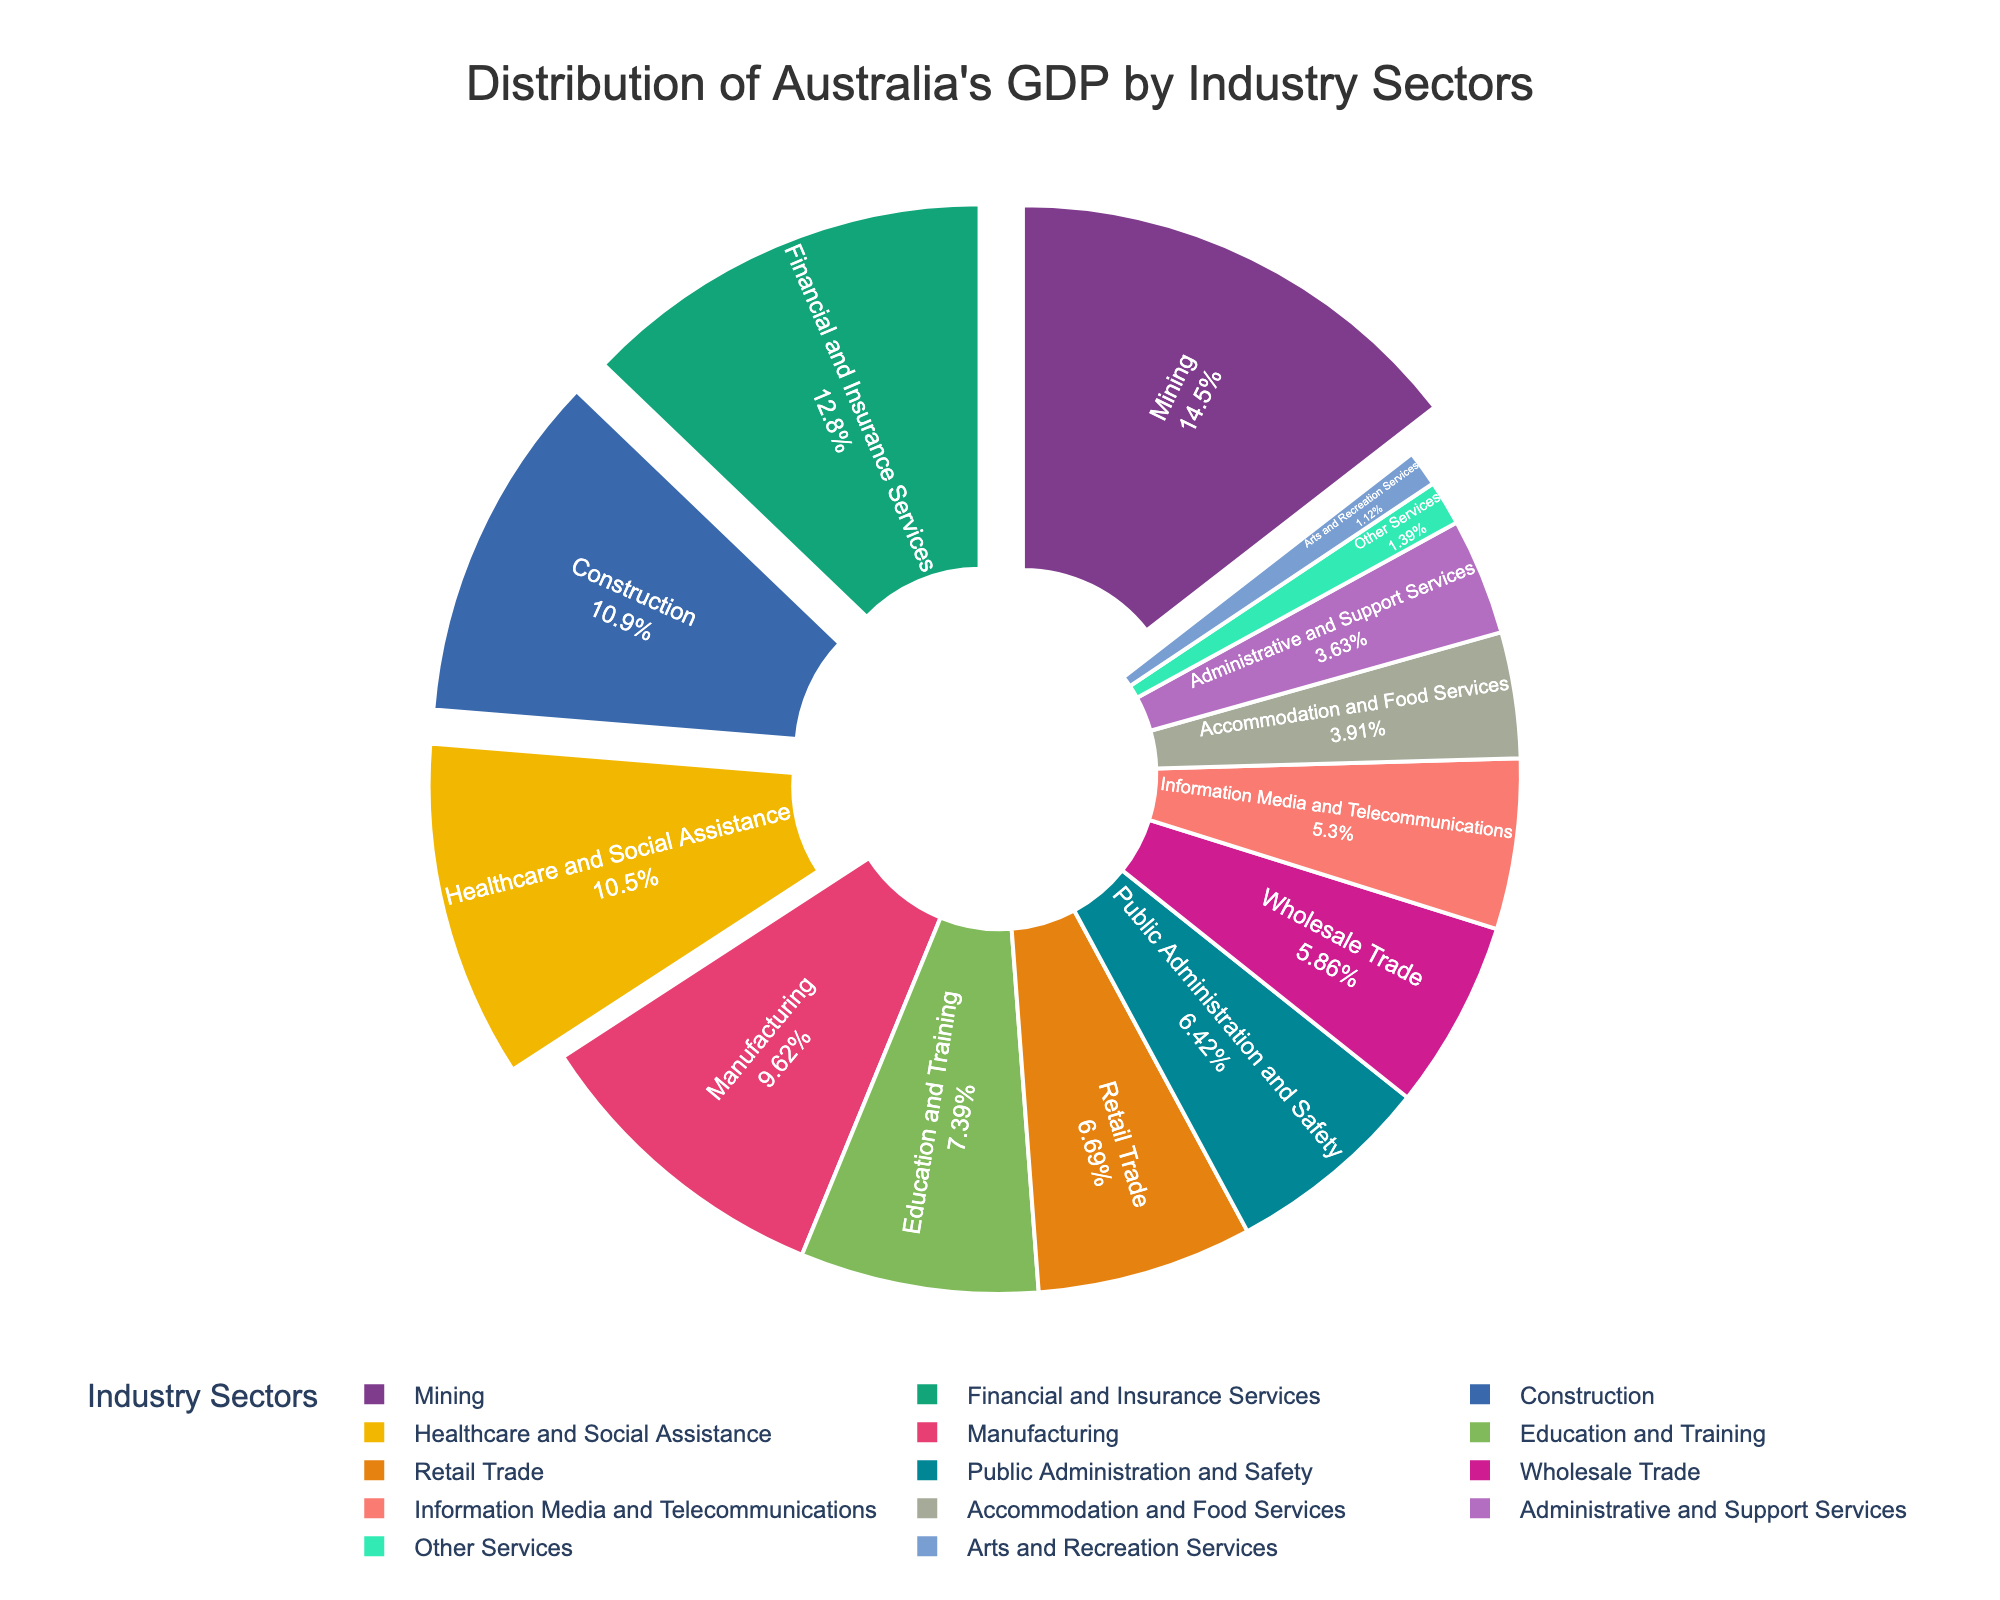What percentage of Australia's GDP is contributed by the Mining sector? The Mining sector contributes 10.4% to Australia's GDP according to the pie chart.
Answer: 10.4% How does the contribution of Financial and Insurance Services compare to that of Construction? Financial and Insurance Services contribute 9.2% while Construction contributes 7.8%. So, Financial and Insurance Services contribute more.
Answer: Financial and Insurance Services contribute more Which industry sector contributes the least to Australia's GDP? The pie chart shows that Arts and Recreation Services contribute the least with 0.8%.
Answer: Arts and Recreation Services What is the combined contribution of Healthcare and Social Assistance and Education and Training? Healthcare and Social Assistance contribute 7.5%, and Education and Training contribute 5.3%. Adding these gives 7.5% + 5.3% = 12.8%.
Answer: 12.8% Which sector is visually represented with the largest slice of the pie chart? The largest slice visually, according to the chart, is the sector with the highest percentage which is the Mining sector at 10.4%.
Answer: Mining sector Is the contribution of the Manufacturing sector greater or less than 7%? The Manufacturing sector contributes 6.9%, which is less than 7%.
Answer: Less than 7% What is the difference in contribution to the GDP between Retail Trade and Wholesale Trade? Retail Trade contributes 4.8% and Wholesale Trade contributes 4.2%, so the difference is 4.8% - 4.2% = 0.6%.
Answer: 0.6% How many sectors contribute more than 5% to Australia’s GDP? The sectors contributing more than 5% are Mining (10.4%), Financial and Insurance Services (9.2%), Construction (7.8%), Healthcare and Social Assistance (7.5%), and Manufacturing (6.9%). There are a total of 5 such sectors.
Answer: 5 sectors Which sectors contribute less than 3% to Australia's GDP? The sectors contributing less than 3% are Accommodation and Food Services (2.8%), Administrative and Support Services (2.6%), Arts and Recreation Services (0.8%), and Other Services (1.0%).
Answer: Accommodation and Food Services, Administrative and Support Services, Arts and Recreation Services, Other Services 